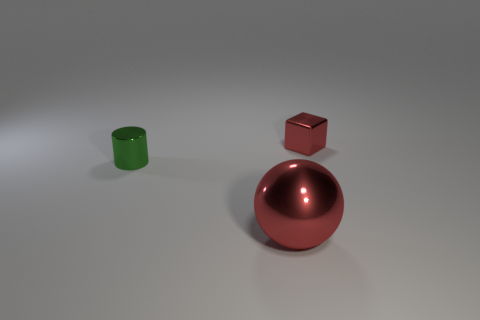Is the number of tiny red objects that are right of the tiny metal cylinder greater than the number of small cyan shiny cylinders?
Ensure brevity in your answer.  Yes. The sphere that is made of the same material as the tiny cylinder is what size?
Make the answer very short. Large. How many other tiny cubes are the same color as the block?
Make the answer very short. 0. Does the tiny metallic thing that is behind the tiny shiny cylinder have the same color as the sphere?
Offer a very short reply. Yes. Is the number of big spheres in front of the big sphere the same as the number of red objects that are behind the small cylinder?
Ensure brevity in your answer.  No. What is the color of the small shiny object that is in front of the tiny red metallic cube?
Your answer should be very brief. Green. Are there the same number of red metal things behind the large red object and tiny shiny cylinders?
Provide a short and direct response. Yes. How many other things are there of the same shape as the green object?
Make the answer very short. 0. There is a metallic cylinder; what number of tiny green objects are on the right side of it?
Provide a succinct answer. 0. There is a thing that is right of the small green metallic thing and on the left side of the tiny red metal thing; how big is it?
Give a very brief answer. Large. 